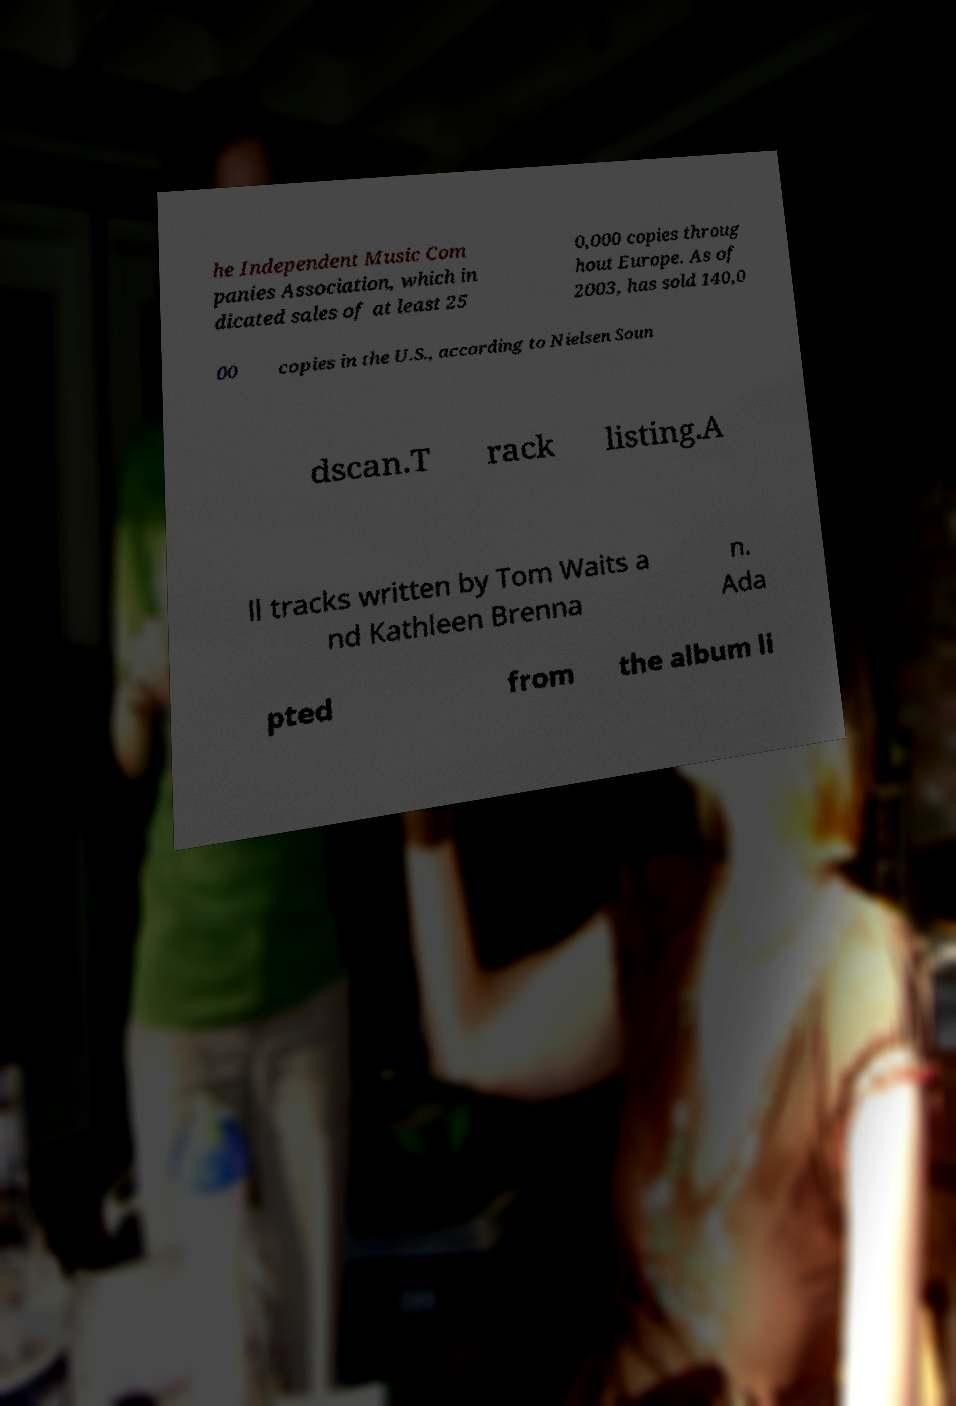Please read and relay the text visible in this image. What does it say? he Independent Music Com panies Association, which in dicated sales of at least 25 0,000 copies throug hout Europe. As of 2003, has sold 140,0 00 copies in the U.S., according to Nielsen Soun dscan.T rack listing.A ll tracks written by Tom Waits a nd Kathleen Brenna n. Ada pted from the album li 